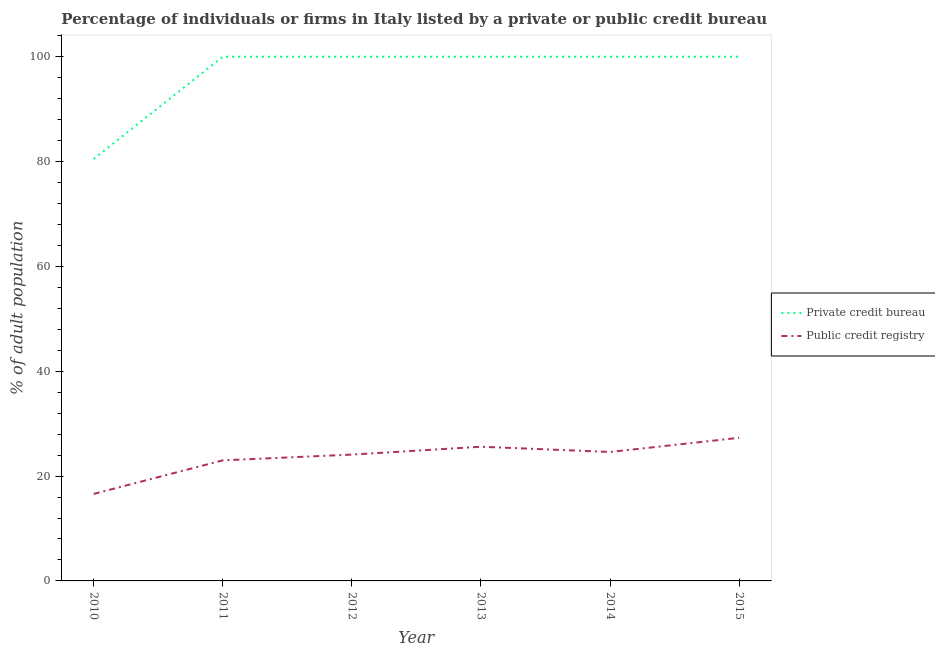Does the line corresponding to percentage of firms listed by private credit bureau intersect with the line corresponding to percentage of firms listed by public credit bureau?
Offer a terse response. No. Is the number of lines equal to the number of legend labels?
Give a very brief answer. Yes. What is the percentage of firms listed by public credit bureau in 2011?
Keep it short and to the point. 23. Across all years, what is the minimum percentage of firms listed by public credit bureau?
Provide a short and direct response. 16.6. What is the total percentage of firms listed by private credit bureau in the graph?
Your answer should be compact. 580.5. What is the difference between the percentage of firms listed by private credit bureau in 2014 and the percentage of firms listed by public credit bureau in 2010?
Your answer should be very brief. 83.4. What is the average percentage of firms listed by private credit bureau per year?
Your answer should be very brief. 96.75. In the year 2011, what is the difference between the percentage of firms listed by public credit bureau and percentage of firms listed by private credit bureau?
Give a very brief answer. -77. In how many years, is the percentage of firms listed by public credit bureau greater than 72 %?
Give a very brief answer. 0. What is the ratio of the percentage of firms listed by private credit bureau in 2011 to that in 2014?
Offer a very short reply. 1. Is the difference between the percentage of firms listed by public credit bureau in 2013 and 2014 greater than the difference between the percentage of firms listed by private credit bureau in 2013 and 2014?
Ensure brevity in your answer.  Yes. What is the difference between the highest and the second highest percentage of firms listed by public credit bureau?
Ensure brevity in your answer.  1.7. What is the difference between the highest and the lowest percentage of firms listed by private credit bureau?
Your response must be concise. 19.5. In how many years, is the percentage of firms listed by private credit bureau greater than the average percentage of firms listed by private credit bureau taken over all years?
Your response must be concise. 5. Is the sum of the percentage of firms listed by public credit bureau in 2010 and 2011 greater than the maximum percentage of firms listed by private credit bureau across all years?
Provide a succinct answer. No. Is the percentage of firms listed by public credit bureau strictly greater than the percentage of firms listed by private credit bureau over the years?
Ensure brevity in your answer.  No. What is the difference between two consecutive major ticks on the Y-axis?
Ensure brevity in your answer.  20. Does the graph contain grids?
Provide a short and direct response. No. How many legend labels are there?
Offer a very short reply. 2. How are the legend labels stacked?
Provide a succinct answer. Vertical. What is the title of the graph?
Make the answer very short. Percentage of individuals or firms in Italy listed by a private or public credit bureau. What is the label or title of the Y-axis?
Make the answer very short. % of adult population. What is the % of adult population in Private credit bureau in 2010?
Make the answer very short. 80.5. What is the % of adult population in Public credit registry in 2010?
Your response must be concise. 16.6. What is the % of adult population of Public credit registry in 2012?
Ensure brevity in your answer.  24.1. What is the % of adult population in Private credit bureau in 2013?
Provide a succinct answer. 100. What is the % of adult population in Public credit registry in 2013?
Your answer should be very brief. 25.6. What is the % of adult population of Private credit bureau in 2014?
Ensure brevity in your answer.  100. What is the % of adult population of Public credit registry in 2014?
Your response must be concise. 24.6. What is the % of adult population in Public credit registry in 2015?
Offer a very short reply. 27.3. Across all years, what is the maximum % of adult population of Private credit bureau?
Your response must be concise. 100. Across all years, what is the maximum % of adult population in Public credit registry?
Provide a short and direct response. 27.3. Across all years, what is the minimum % of adult population in Private credit bureau?
Your answer should be compact. 80.5. What is the total % of adult population in Private credit bureau in the graph?
Your response must be concise. 580.5. What is the total % of adult population in Public credit registry in the graph?
Make the answer very short. 141.2. What is the difference between the % of adult population of Private credit bureau in 2010 and that in 2011?
Your answer should be very brief. -19.5. What is the difference between the % of adult population in Public credit registry in 2010 and that in 2011?
Provide a short and direct response. -6.4. What is the difference between the % of adult population of Private credit bureau in 2010 and that in 2012?
Offer a terse response. -19.5. What is the difference between the % of adult population of Public credit registry in 2010 and that in 2012?
Keep it short and to the point. -7.5. What is the difference between the % of adult population in Private credit bureau in 2010 and that in 2013?
Offer a terse response. -19.5. What is the difference between the % of adult population of Public credit registry in 2010 and that in 2013?
Keep it short and to the point. -9. What is the difference between the % of adult population in Private credit bureau in 2010 and that in 2014?
Your response must be concise. -19.5. What is the difference between the % of adult population in Public credit registry in 2010 and that in 2014?
Provide a succinct answer. -8. What is the difference between the % of adult population of Private credit bureau in 2010 and that in 2015?
Give a very brief answer. -19.5. What is the difference between the % of adult population in Public credit registry in 2010 and that in 2015?
Make the answer very short. -10.7. What is the difference between the % of adult population in Private credit bureau in 2011 and that in 2012?
Provide a succinct answer. 0. What is the difference between the % of adult population in Public credit registry in 2011 and that in 2012?
Your response must be concise. -1.1. What is the difference between the % of adult population of Public credit registry in 2011 and that in 2014?
Offer a very short reply. -1.6. What is the difference between the % of adult population of Private credit bureau in 2012 and that in 2013?
Give a very brief answer. 0. What is the difference between the % of adult population of Public credit registry in 2012 and that in 2013?
Make the answer very short. -1.5. What is the difference between the % of adult population of Public credit registry in 2012 and that in 2014?
Ensure brevity in your answer.  -0.5. What is the difference between the % of adult population in Private credit bureau in 2012 and that in 2015?
Provide a succinct answer. 0. What is the difference between the % of adult population of Public credit registry in 2012 and that in 2015?
Your answer should be very brief. -3.2. What is the difference between the % of adult population of Private credit bureau in 2013 and that in 2014?
Give a very brief answer. 0. What is the difference between the % of adult population in Private credit bureau in 2010 and the % of adult population in Public credit registry in 2011?
Your response must be concise. 57.5. What is the difference between the % of adult population of Private credit bureau in 2010 and the % of adult population of Public credit registry in 2012?
Keep it short and to the point. 56.4. What is the difference between the % of adult population of Private credit bureau in 2010 and the % of adult population of Public credit registry in 2013?
Make the answer very short. 54.9. What is the difference between the % of adult population of Private credit bureau in 2010 and the % of adult population of Public credit registry in 2014?
Provide a short and direct response. 55.9. What is the difference between the % of adult population in Private credit bureau in 2010 and the % of adult population in Public credit registry in 2015?
Provide a succinct answer. 53.2. What is the difference between the % of adult population of Private credit bureau in 2011 and the % of adult population of Public credit registry in 2012?
Ensure brevity in your answer.  75.9. What is the difference between the % of adult population of Private credit bureau in 2011 and the % of adult population of Public credit registry in 2013?
Your answer should be compact. 74.4. What is the difference between the % of adult population of Private credit bureau in 2011 and the % of adult population of Public credit registry in 2014?
Offer a very short reply. 75.4. What is the difference between the % of adult population in Private credit bureau in 2011 and the % of adult population in Public credit registry in 2015?
Your answer should be compact. 72.7. What is the difference between the % of adult population of Private credit bureau in 2012 and the % of adult population of Public credit registry in 2013?
Provide a short and direct response. 74.4. What is the difference between the % of adult population in Private credit bureau in 2012 and the % of adult population in Public credit registry in 2014?
Your response must be concise. 75.4. What is the difference between the % of adult population in Private credit bureau in 2012 and the % of adult population in Public credit registry in 2015?
Keep it short and to the point. 72.7. What is the difference between the % of adult population in Private credit bureau in 2013 and the % of adult population in Public credit registry in 2014?
Provide a short and direct response. 75.4. What is the difference between the % of adult population in Private credit bureau in 2013 and the % of adult population in Public credit registry in 2015?
Your answer should be compact. 72.7. What is the difference between the % of adult population in Private credit bureau in 2014 and the % of adult population in Public credit registry in 2015?
Your answer should be very brief. 72.7. What is the average % of adult population in Private credit bureau per year?
Provide a succinct answer. 96.75. What is the average % of adult population in Public credit registry per year?
Keep it short and to the point. 23.53. In the year 2010, what is the difference between the % of adult population of Private credit bureau and % of adult population of Public credit registry?
Keep it short and to the point. 63.9. In the year 2011, what is the difference between the % of adult population in Private credit bureau and % of adult population in Public credit registry?
Keep it short and to the point. 77. In the year 2012, what is the difference between the % of adult population of Private credit bureau and % of adult population of Public credit registry?
Provide a succinct answer. 75.9. In the year 2013, what is the difference between the % of adult population in Private credit bureau and % of adult population in Public credit registry?
Provide a succinct answer. 74.4. In the year 2014, what is the difference between the % of adult population of Private credit bureau and % of adult population of Public credit registry?
Provide a short and direct response. 75.4. In the year 2015, what is the difference between the % of adult population in Private credit bureau and % of adult population in Public credit registry?
Your response must be concise. 72.7. What is the ratio of the % of adult population of Private credit bureau in 2010 to that in 2011?
Provide a succinct answer. 0.81. What is the ratio of the % of adult population of Public credit registry in 2010 to that in 2011?
Provide a succinct answer. 0.72. What is the ratio of the % of adult population of Private credit bureau in 2010 to that in 2012?
Make the answer very short. 0.81. What is the ratio of the % of adult population in Public credit registry in 2010 to that in 2012?
Give a very brief answer. 0.69. What is the ratio of the % of adult population of Private credit bureau in 2010 to that in 2013?
Provide a short and direct response. 0.81. What is the ratio of the % of adult population of Public credit registry in 2010 to that in 2013?
Provide a short and direct response. 0.65. What is the ratio of the % of adult population in Private credit bureau in 2010 to that in 2014?
Give a very brief answer. 0.81. What is the ratio of the % of adult population in Public credit registry in 2010 to that in 2014?
Make the answer very short. 0.67. What is the ratio of the % of adult population of Private credit bureau in 2010 to that in 2015?
Offer a very short reply. 0.81. What is the ratio of the % of adult population in Public credit registry in 2010 to that in 2015?
Make the answer very short. 0.61. What is the ratio of the % of adult population in Public credit registry in 2011 to that in 2012?
Offer a terse response. 0.95. What is the ratio of the % of adult population in Private credit bureau in 2011 to that in 2013?
Your response must be concise. 1. What is the ratio of the % of adult population in Public credit registry in 2011 to that in 2013?
Give a very brief answer. 0.9. What is the ratio of the % of adult population in Public credit registry in 2011 to that in 2014?
Offer a terse response. 0.94. What is the ratio of the % of adult population in Public credit registry in 2011 to that in 2015?
Make the answer very short. 0.84. What is the ratio of the % of adult population in Public credit registry in 2012 to that in 2013?
Ensure brevity in your answer.  0.94. What is the ratio of the % of adult population of Private credit bureau in 2012 to that in 2014?
Make the answer very short. 1. What is the ratio of the % of adult population in Public credit registry in 2012 to that in 2014?
Provide a succinct answer. 0.98. What is the ratio of the % of adult population of Private credit bureau in 2012 to that in 2015?
Offer a very short reply. 1. What is the ratio of the % of adult population of Public credit registry in 2012 to that in 2015?
Your answer should be compact. 0.88. What is the ratio of the % of adult population of Public credit registry in 2013 to that in 2014?
Keep it short and to the point. 1.04. What is the ratio of the % of adult population in Private credit bureau in 2013 to that in 2015?
Your response must be concise. 1. What is the ratio of the % of adult population of Public credit registry in 2013 to that in 2015?
Your response must be concise. 0.94. What is the ratio of the % of adult population of Public credit registry in 2014 to that in 2015?
Give a very brief answer. 0.9. What is the difference between the highest and the second highest % of adult population of Private credit bureau?
Keep it short and to the point. 0. What is the difference between the highest and the lowest % of adult population of Private credit bureau?
Provide a short and direct response. 19.5. What is the difference between the highest and the lowest % of adult population of Public credit registry?
Ensure brevity in your answer.  10.7. 